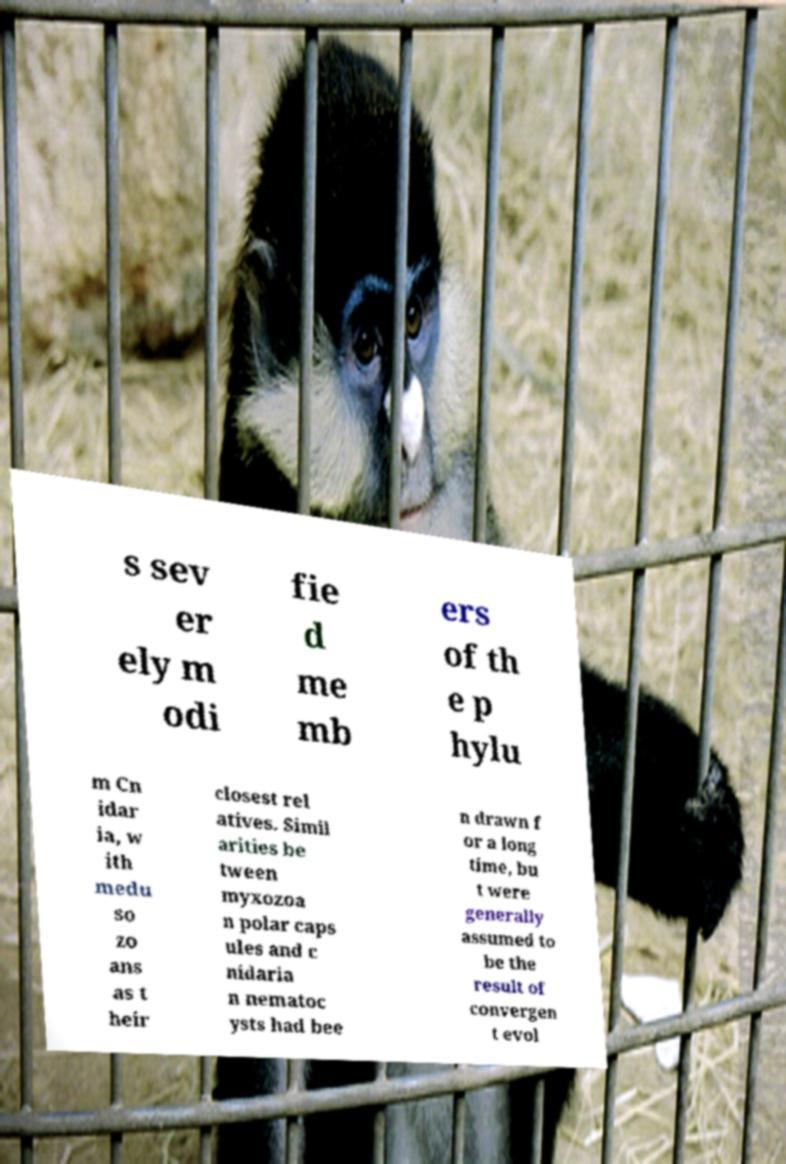Please read and relay the text visible in this image. What does it say? s sev er ely m odi fie d me mb ers of th e p hylu m Cn idar ia, w ith medu so zo ans as t heir closest rel atives. Simil arities be tween myxozoa n polar caps ules and c nidaria n nematoc ysts had bee n drawn f or a long time, bu t were generally assumed to be the result of convergen t evol 